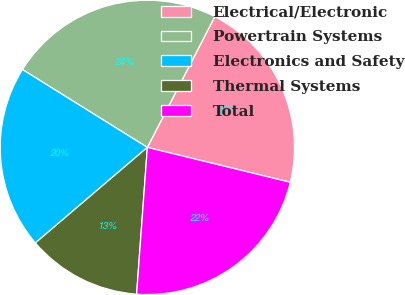Convert chart to OTSL. <chart><loc_0><loc_0><loc_500><loc_500><pie_chart><fcel>Electrical/Electronic<fcel>Powertrain Systems<fcel>Electronics and Safety<fcel>Thermal Systems<fcel>Total<nl><fcel>21.23%<fcel>23.7%<fcel>20.12%<fcel>12.59%<fcel>22.35%<nl></chart> 